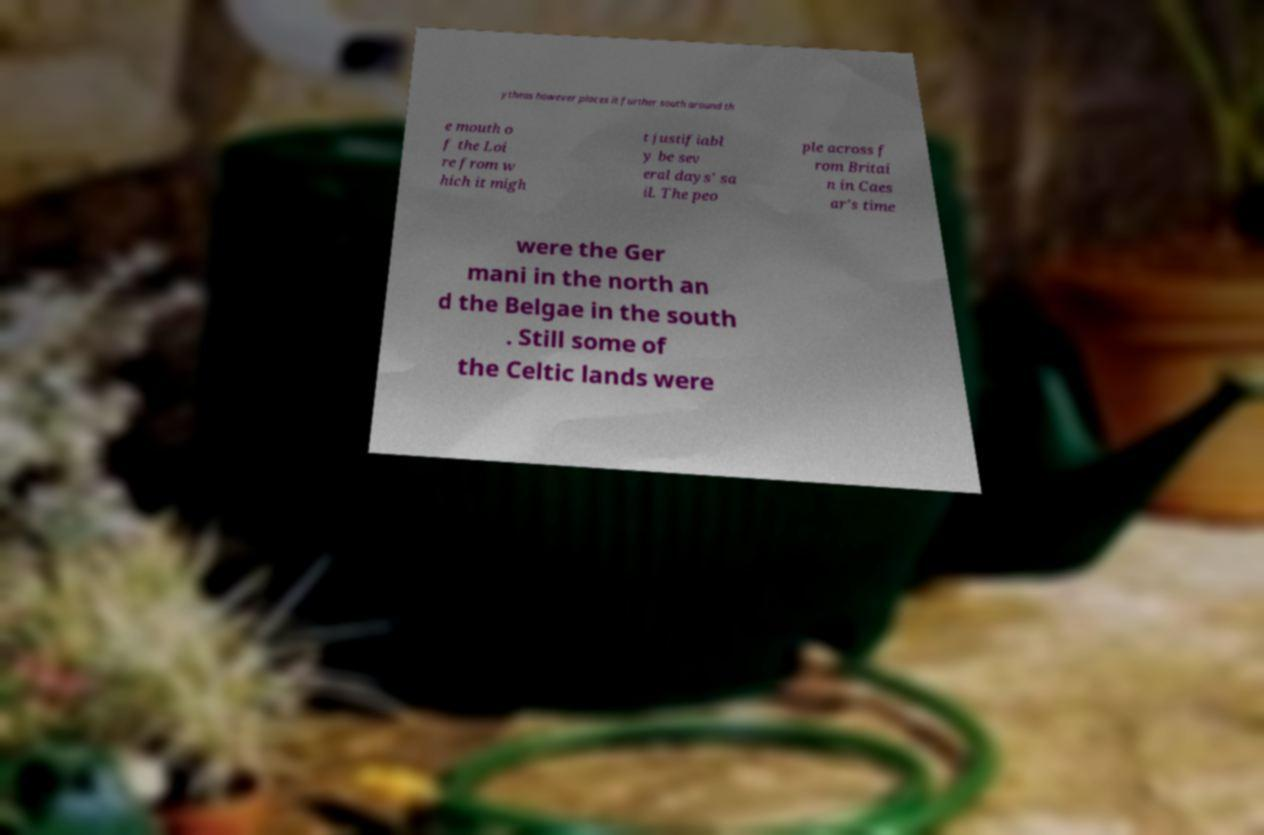What messages or text are displayed in this image? I need them in a readable, typed format. ytheas however places it further south around th e mouth o f the Loi re from w hich it migh t justifiabl y be sev eral days' sa il. The peo ple across f rom Britai n in Caes ar's time were the Ger mani in the north an d the Belgae in the south . Still some of the Celtic lands were 